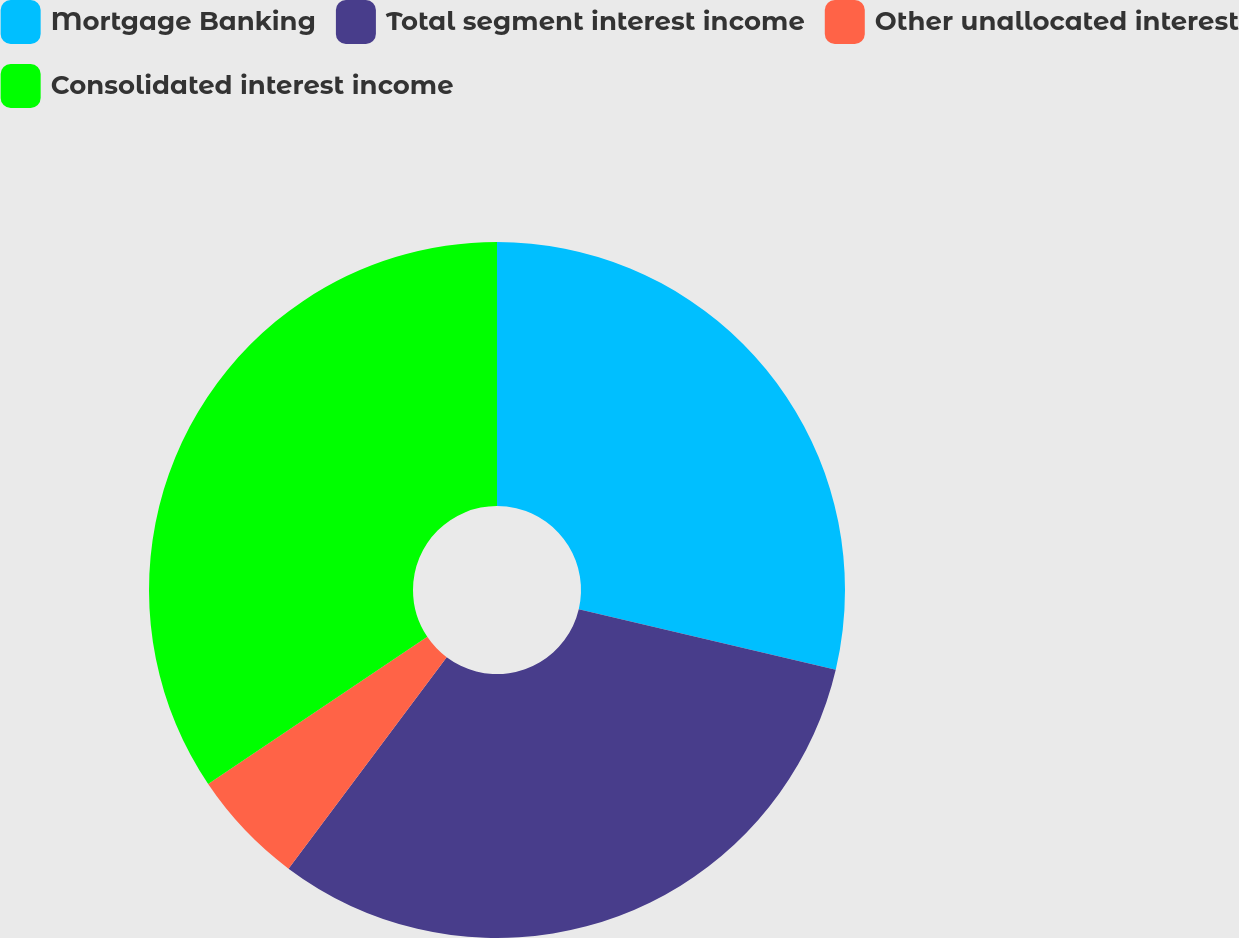Convert chart to OTSL. <chart><loc_0><loc_0><loc_500><loc_500><pie_chart><fcel>Mortgage Banking<fcel>Total segment interest income<fcel>Other unallocated interest<fcel>Consolidated interest income<nl><fcel>28.68%<fcel>31.55%<fcel>5.36%<fcel>34.42%<nl></chart> 